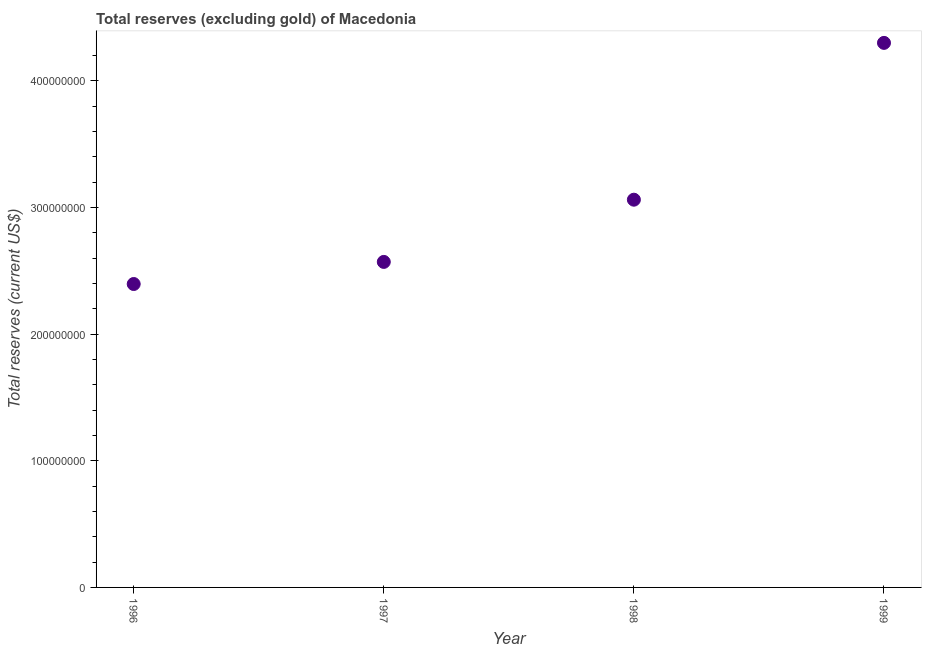What is the total reserves (excluding gold) in 1997?
Give a very brief answer. 2.57e+08. Across all years, what is the maximum total reserves (excluding gold)?
Ensure brevity in your answer.  4.30e+08. Across all years, what is the minimum total reserves (excluding gold)?
Provide a succinct answer. 2.40e+08. What is the sum of the total reserves (excluding gold)?
Keep it short and to the point. 1.23e+09. What is the difference between the total reserves (excluding gold) in 1996 and 1999?
Offer a very short reply. -1.90e+08. What is the average total reserves (excluding gold) per year?
Offer a very short reply. 3.08e+08. What is the median total reserves (excluding gold)?
Give a very brief answer. 2.82e+08. In how many years, is the total reserves (excluding gold) greater than 180000000 US$?
Your answer should be very brief. 4. What is the ratio of the total reserves (excluding gold) in 1997 to that in 1999?
Your response must be concise. 0.6. Is the difference between the total reserves (excluding gold) in 1998 and 1999 greater than the difference between any two years?
Your answer should be very brief. No. What is the difference between the highest and the second highest total reserves (excluding gold)?
Provide a succinct answer. 1.24e+08. What is the difference between the highest and the lowest total reserves (excluding gold)?
Your answer should be compact. 1.90e+08. How many dotlines are there?
Ensure brevity in your answer.  1. How many years are there in the graph?
Your response must be concise. 4. What is the difference between two consecutive major ticks on the Y-axis?
Offer a terse response. 1.00e+08. Does the graph contain any zero values?
Offer a terse response. No. Does the graph contain grids?
Offer a terse response. No. What is the title of the graph?
Your response must be concise. Total reserves (excluding gold) of Macedonia. What is the label or title of the Y-axis?
Your answer should be compact. Total reserves (current US$). What is the Total reserves (current US$) in 1996?
Give a very brief answer. 2.40e+08. What is the Total reserves (current US$) in 1997?
Keep it short and to the point. 2.57e+08. What is the Total reserves (current US$) in 1998?
Your answer should be compact. 3.06e+08. What is the Total reserves (current US$) in 1999?
Give a very brief answer. 4.30e+08. What is the difference between the Total reserves (current US$) in 1996 and 1997?
Provide a short and direct response. -1.75e+07. What is the difference between the Total reserves (current US$) in 1996 and 1998?
Your answer should be very brief. -6.66e+07. What is the difference between the Total reserves (current US$) in 1996 and 1999?
Your answer should be compact. -1.90e+08. What is the difference between the Total reserves (current US$) in 1997 and 1998?
Your response must be concise. -4.91e+07. What is the difference between the Total reserves (current US$) in 1997 and 1999?
Ensure brevity in your answer.  -1.73e+08. What is the difference between the Total reserves (current US$) in 1998 and 1999?
Your answer should be very brief. -1.24e+08. What is the ratio of the Total reserves (current US$) in 1996 to that in 1997?
Keep it short and to the point. 0.93. What is the ratio of the Total reserves (current US$) in 1996 to that in 1998?
Provide a short and direct response. 0.78. What is the ratio of the Total reserves (current US$) in 1996 to that in 1999?
Give a very brief answer. 0.56. What is the ratio of the Total reserves (current US$) in 1997 to that in 1998?
Offer a very short reply. 0.84. What is the ratio of the Total reserves (current US$) in 1997 to that in 1999?
Provide a short and direct response. 0.6. What is the ratio of the Total reserves (current US$) in 1998 to that in 1999?
Give a very brief answer. 0.71. 